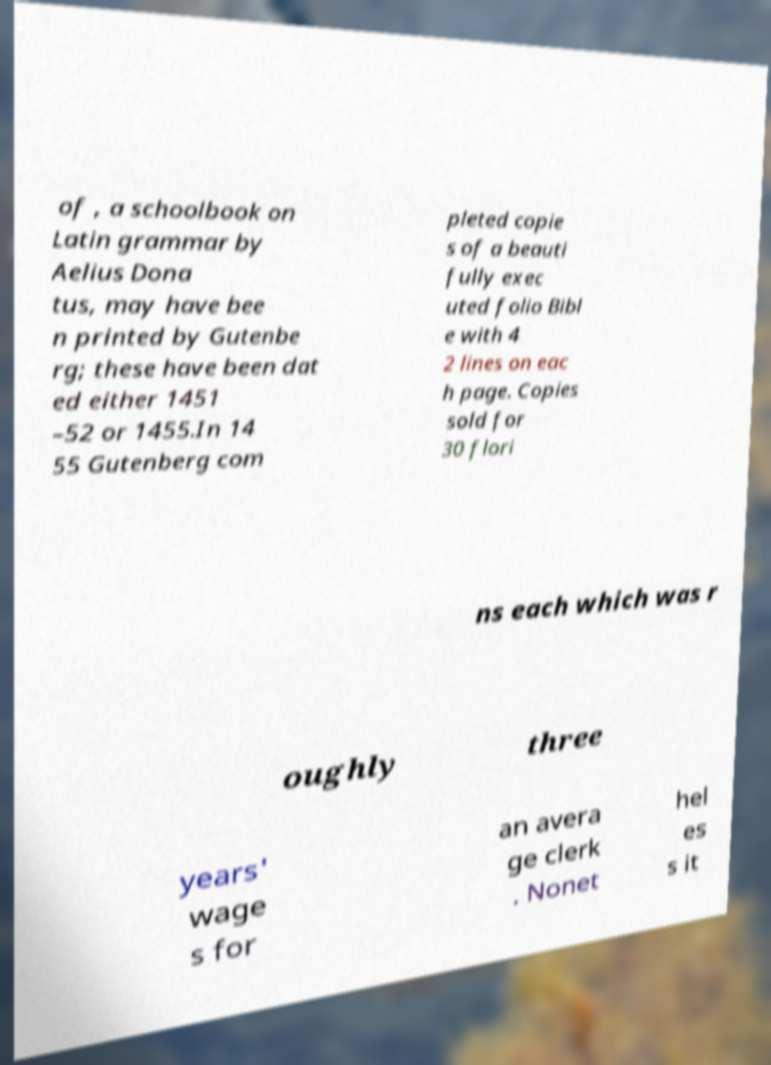For documentation purposes, I need the text within this image transcribed. Could you provide that? of , a schoolbook on Latin grammar by Aelius Dona tus, may have bee n printed by Gutenbe rg; these have been dat ed either 1451 –52 or 1455.In 14 55 Gutenberg com pleted copie s of a beauti fully exec uted folio Bibl e with 4 2 lines on eac h page. Copies sold for 30 flori ns each which was r oughly three years' wage s for an avera ge clerk . Nonet hel es s it 